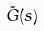<formula> <loc_0><loc_0><loc_500><loc_500>\tilde { G } ( s )</formula> 